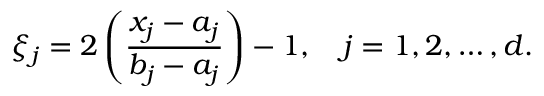Convert formula to latex. <formula><loc_0><loc_0><loc_500><loc_500>\xi _ { j } = 2 \left ( \frac { x _ { j } - a _ { j } } { b _ { j } - a _ { j } } \right ) - 1 , \quad j = 1 , 2 , \dots , d .</formula> 